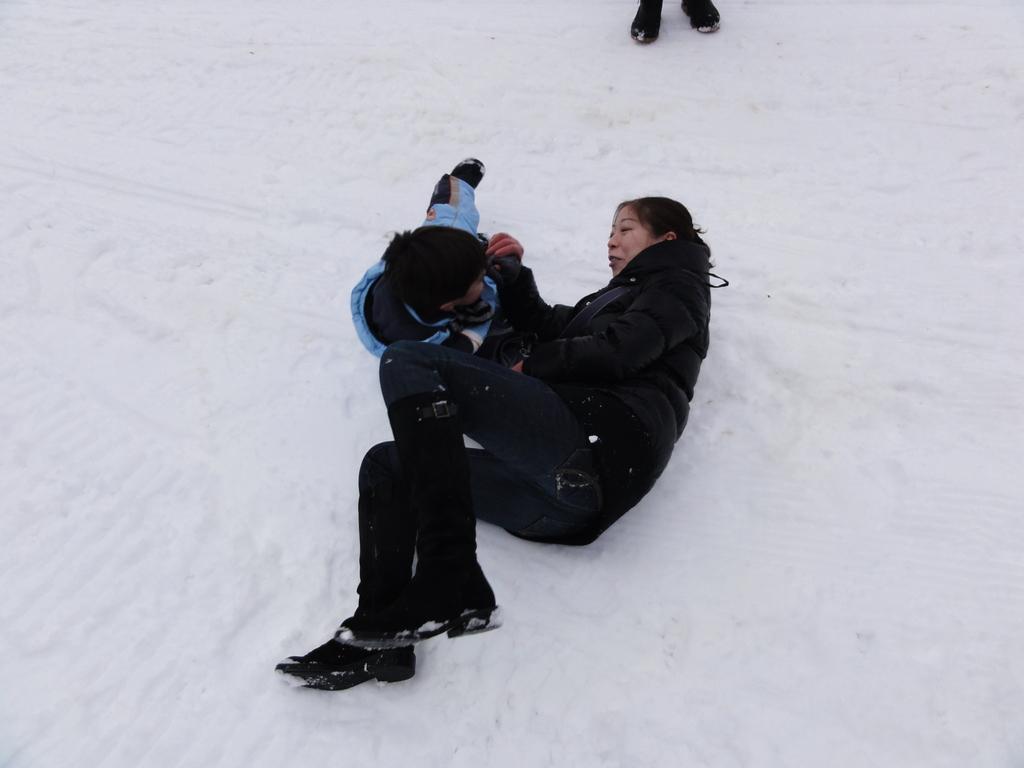In one or two sentences, can you explain what this image depicts? In this picture we can see woman leaning on the ground and playing with the boy. Women wore black color jacket and boy wore blue color jacket. They both are on the snow and here it is shoe. 